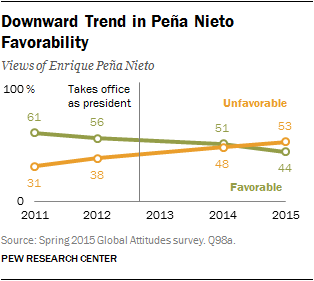Mention a couple of crucial points in this snapshot. The sum favorable value in the years 2014 and 2015 is 95. The value was 51 in 2014. 